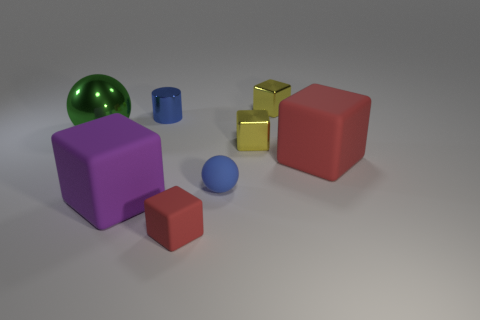Subtract all large purple blocks. How many blocks are left? 4 Add 1 red rubber blocks. How many objects exist? 9 Subtract all red blocks. How many blocks are left? 3 Subtract all cylinders. How many objects are left? 7 Subtract 1 cubes. How many cubes are left? 4 Subtract all gray cubes. Subtract all gray cylinders. How many cubes are left? 5 Subtract all gray cylinders. How many green balls are left? 1 Add 5 yellow metal objects. How many yellow metal objects are left? 7 Add 4 big purple matte blocks. How many big purple matte blocks exist? 5 Subtract 0 cyan spheres. How many objects are left? 8 